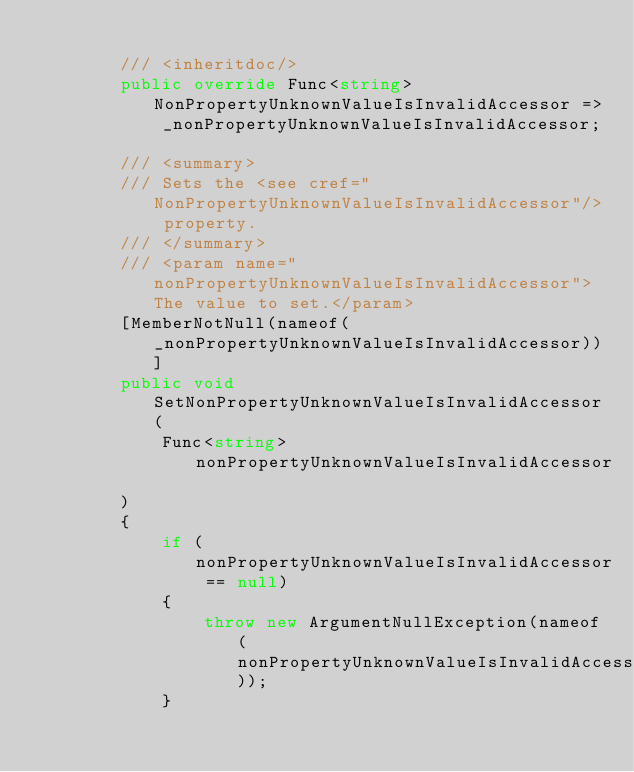<code> <loc_0><loc_0><loc_500><loc_500><_C#_>
        /// <inheritdoc/>
        public override Func<string> NonPropertyUnknownValueIsInvalidAccessor =>
            _nonPropertyUnknownValueIsInvalidAccessor;

        /// <summary>
        /// Sets the <see cref="NonPropertyUnknownValueIsInvalidAccessor"/> property.
        /// </summary>
        /// <param name="nonPropertyUnknownValueIsInvalidAccessor">The value to set.</param>
        [MemberNotNull(nameof(_nonPropertyUnknownValueIsInvalidAccessor))]
        public void SetNonPropertyUnknownValueIsInvalidAccessor(
            Func<string> nonPropertyUnknownValueIsInvalidAccessor
        )
        {
            if (nonPropertyUnknownValueIsInvalidAccessor == null)
            {
                throw new ArgumentNullException(nameof(nonPropertyUnknownValueIsInvalidAccessor));
            }
</code> 